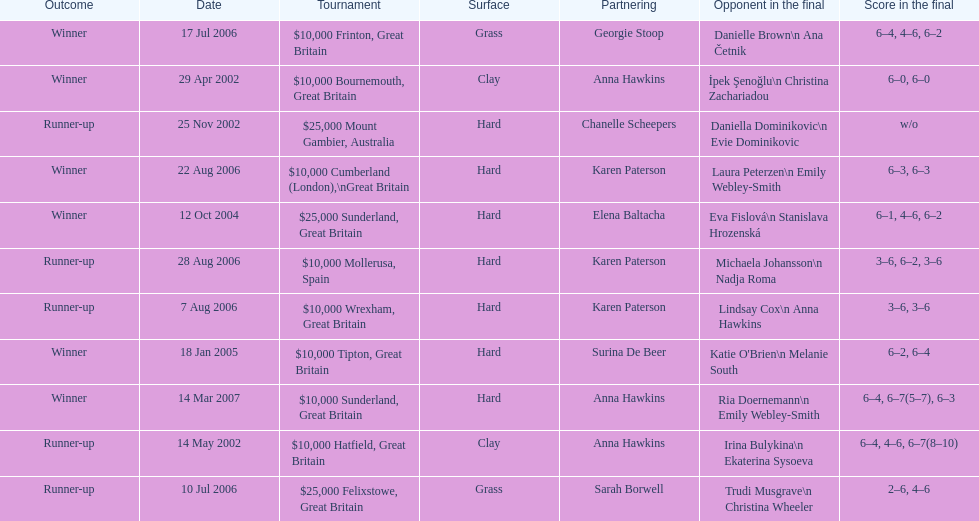How many were played on a hard surface? 7. 